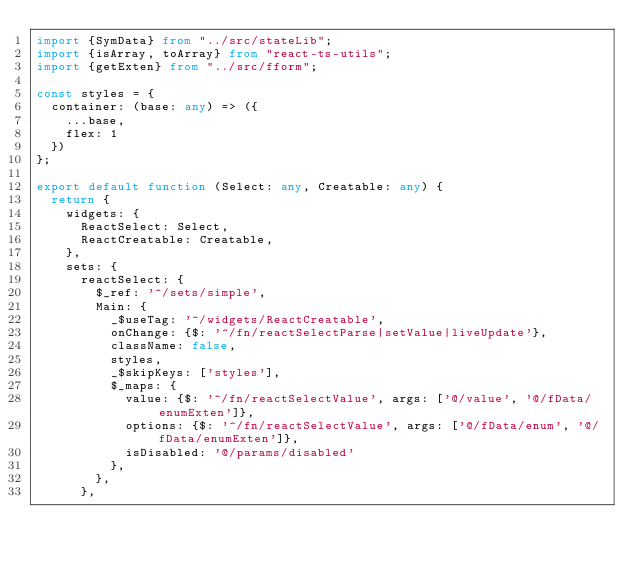Convert code to text. <code><loc_0><loc_0><loc_500><loc_500><_TypeScript_>import {SymData} from "../src/stateLib";
import {isArray, toArray} from "react-ts-utils";
import {getExten} from "../src/fform";

const styles = {
  container: (base: any) => ({
    ...base,
    flex: 1
  })
};

export default function (Select: any, Creatable: any) {
  return {
    widgets: {
      ReactSelect: Select,
      ReactCreatable: Creatable,
    },
    sets: {
      reactSelect: {
        $_ref: '^/sets/simple',
        Main: {
          _$useTag: '^/widgets/ReactCreatable',
          onChange: {$: '^/fn/reactSelectParse|setValue|liveUpdate'},
          className: false,
          styles,
          _$skipKeys: ['styles'],
          $_maps: {
            value: {$: '^/fn/reactSelectValue', args: ['@/value', '@/fData/enumExten']},
            options: {$: '^/fn/reactSelectValue', args: ['@/fData/enum', '@/fData/enumExten']},
            isDisabled: '@/params/disabled'
          },
        },
      },</code> 